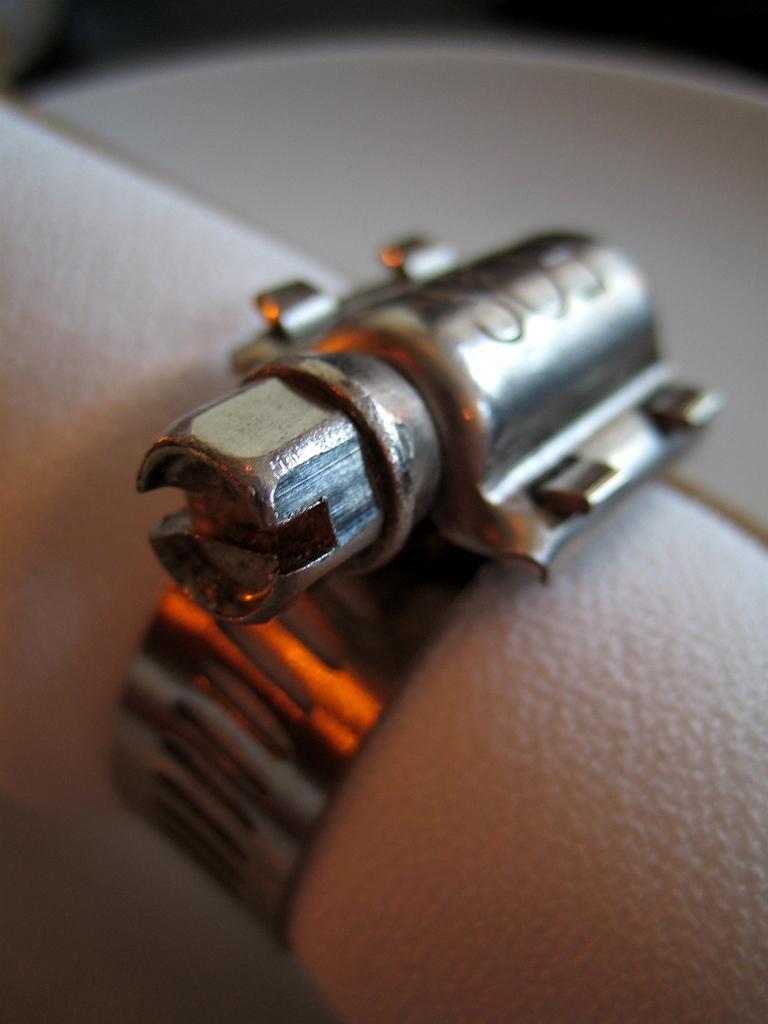In one or two sentences, can you explain what this image depicts? This picture looks like a metal joint to a hand. 